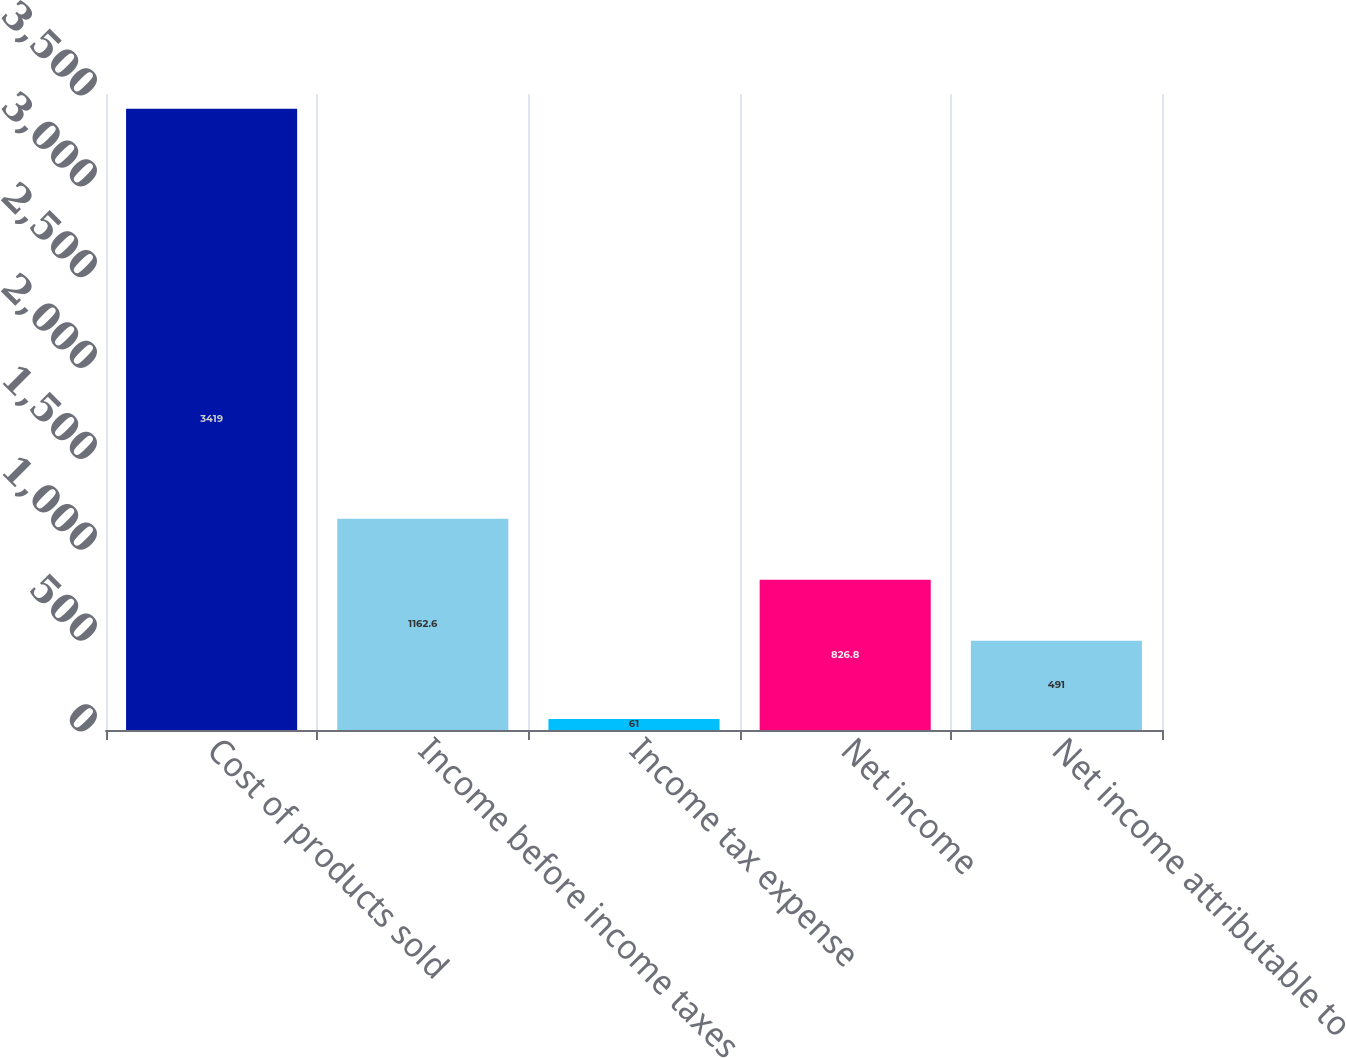Convert chart. <chart><loc_0><loc_0><loc_500><loc_500><bar_chart><fcel>Cost of products sold<fcel>Income before income taxes<fcel>Income tax expense<fcel>Net income<fcel>Net income attributable to<nl><fcel>3419<fcel>1162.6<fcel>61<fcel>826.8<fcel>491<nl></chart> 